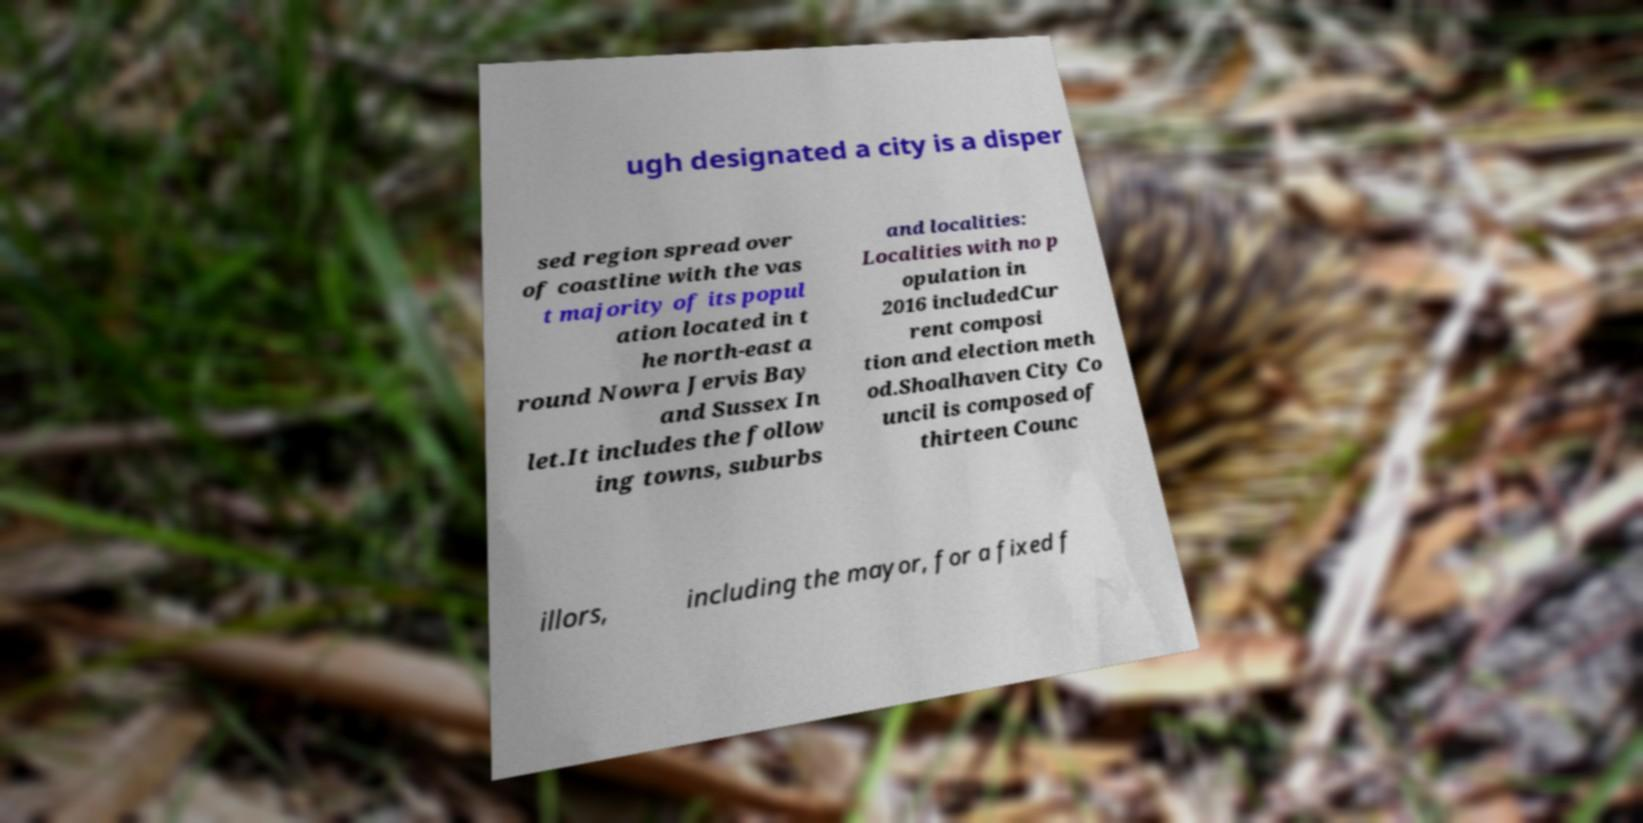I need the written content from this picture converted into text. Can you do that? ugh designated a city is a disper sed region spread over of coastline with the vas t majority of its popul ation located in t he north-east a round Nowra Jervis Bay and Sussex In let.It includes the follow ing towns, suburbs and localities: Localities with no p opulation in 2016 includedCur rent composi tion and election meth od.Shoalhaven City Co uncil is composed of thirteen Counc illors, including the mayor, for a fixed f 